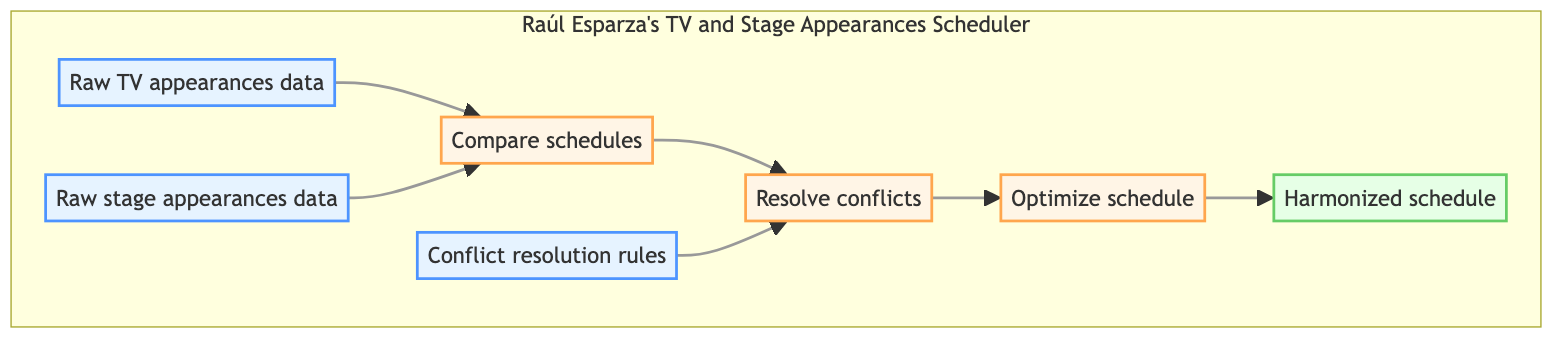What is the output of the diagram? The output node at the top of the flowchart is named "Harmonized schedule," which indicates this is the end result of the entire process in the diagram.
Answer: Harmonized schedule How many data nodes are there in the diagram? There are three data nodes: "Raw TV appearances data," "Raw stage appearances data," and "Conflict resolution rules." Counting these gives a total of three data nodes.
Answer: 3 What is the first process in the flowchart? The first process, as indicated by the flow from the bottom, is "Compare schedules," which takes raw data as input to begin the scheduling harmonization.
Answer: Compare schedules What inputs are required for "Resolve conflicts"? The inputs for this process are "Compare schedules" and "Conflict resolution rules." These together help in resolving any identified conflicts.
Answer: Compare schedules, Conflict resolution rules Which process directly leads to the output? The process that directly leads to the output "Harmonized schedule" is "Optimize schedule." This shows that optimization occurs just before finalizing the harmonized result.
Answer: Optimize schedule What role does "Conflict resolution rules" play in the diagram? "Conflict resolution rules" provides the necessary guidelines for the "Resolve conflicts" process, indicating its importance in determining how conflicts are managed between schedules.
Answer: Guidelines for resolving conflicts Which two nodes feed into the "Compare schedules" process? The two nodes that feed into "Compare schedules" are "Raw TV appearances data" and "Raw stage appearances data." These provide the necessary information to assess any conflicts.
Answer: Raw TV appearances data, Raw stage appearances data How does the flowchart handle scheduling conflicts? The diagram shows that scheduling conflicts are identified through "Compare schedules" and then addressed in the "Resolve conflicts" process by applying "Conflict resolution rules." This indicates a systematic approach to managing conflicts.
Answer: Systematic resolution of conflicts What is the last process depicted in the diagram? The last process before reaching the final output is "Optimize schedule," which indicates an optimization phase happening just prior to generating the result.
Answer: Optimize schedule 